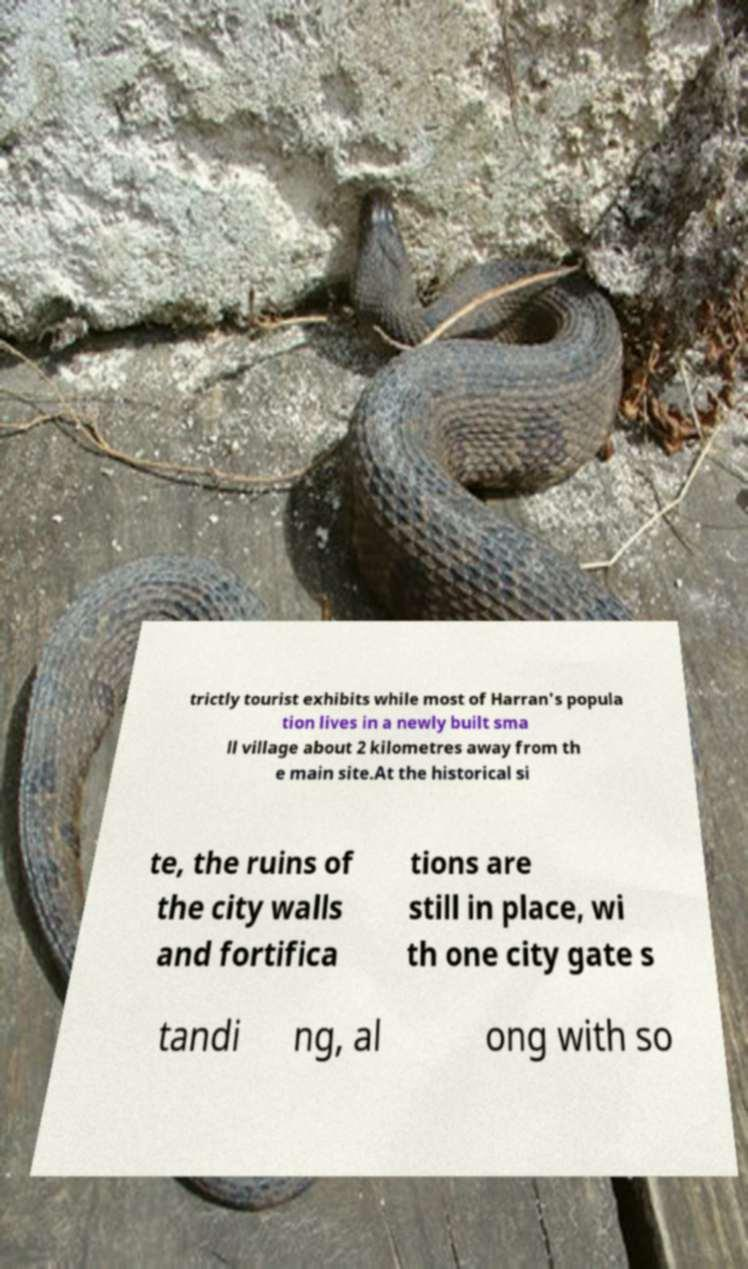Can you read and provide the text displayed in the image?This photo seems to have some interesting text. Can you extract and type it out for me? trictly tourist exhibits while most of Harran's popula tion lives in a newly built sma ll village about 2 kilometres away from th e main site.At the historical si te, the ruins of the city walls and fortifica tions are still in place, wi th one city gate s tandi ng, al ong with so 